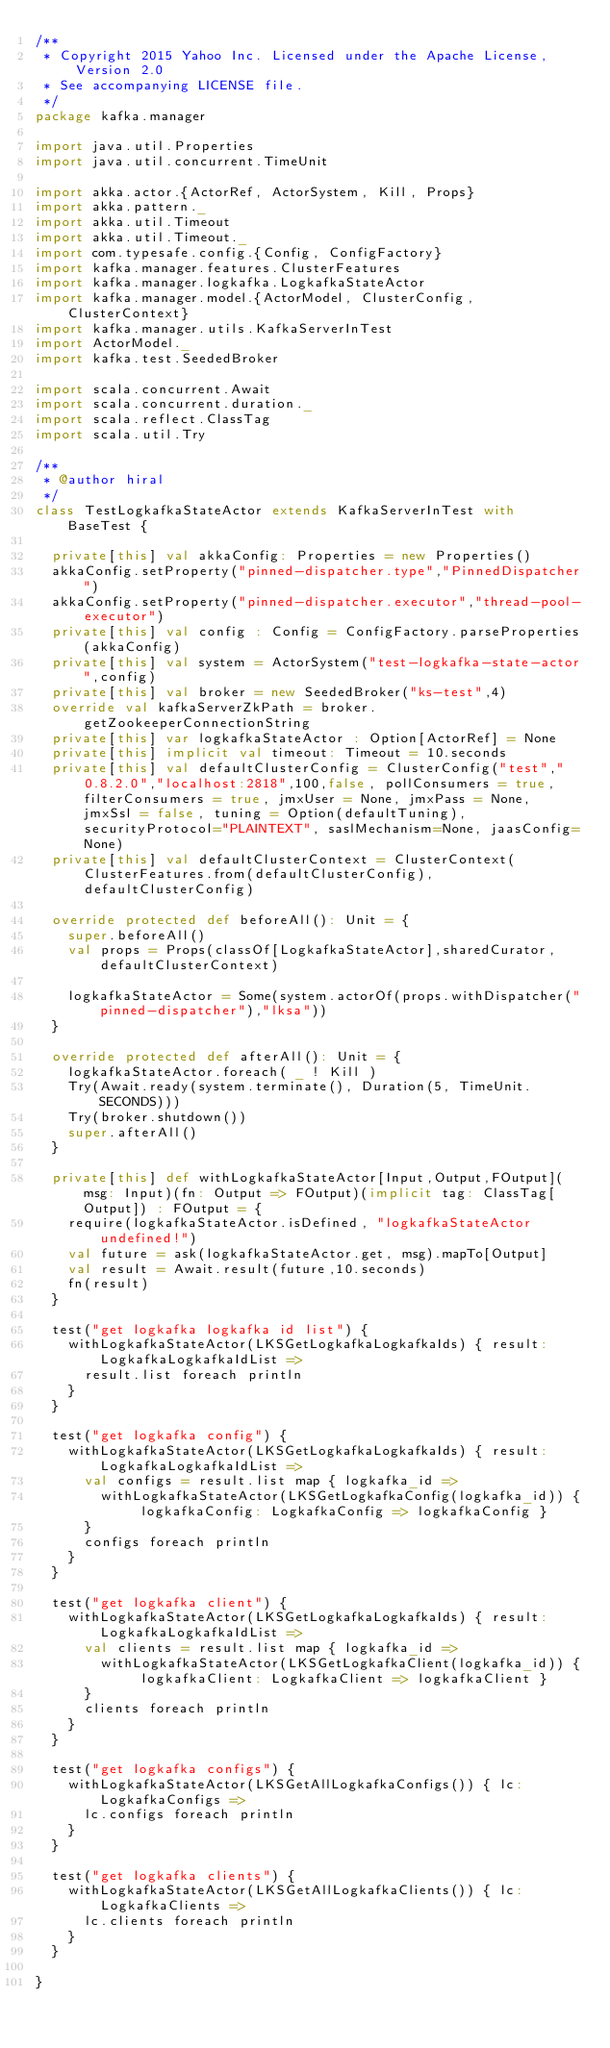Convert code to text. <code><loc_0><loc_0><loc_500><loc_500><_Scala_>/**
 * Copyright 2015 Yahoo Inc. Licensed under the Apache License, Version 2.0
 * See accompanying LICENSE file.
 */
package kafka.manager

import java.util.Properties
import java.util.concurrent.TimeUnit

import akka.actor.{ActorRef, ActorSystem, Kill, Props}
import akka.pattern._
import akka.util.Timeout
import akka.util.Timeout._
import com.typesafe.config.{Config, ConfigFactory}
import kafka.manager.features.ClusterFeatures
import kafka.manager.logkafka.LogkafkaStateActor
import kafka.manager.model.{ActorModel, ClusterConfig, ClusterContext}
import kafka.manager.utils.KafkaServerInTest
import ActorModel._
import kafka.test.SeededBroker

import scala.concurrent.Await
import scala.concurrent.duration._
import scala.reflect.ClassTag
import scala.util.Try

/**
 * @author hiral
 */
class TestLogkafkaStateActor extends KafkaServerInTest with BaseTest {

  private[this] val akkaConfig: Properties = new Properties()
  akkaConfig.setProperty("pinned-dispatcher.type","PinnedDispatcher")
  akkaConfig.setProperty("pinned-dispatcher.executor","thread-pool-executor")
  private[this] val config : Config = ConfigFactory.parseProperties(akkaConfig)
  private[this] val system = ActorSystem("test-logkafka-state-actor",config)
  private[this] val broker = new SeededBroker("ks-test",4)
  override val kafkaServerZkPath = broker.getZookeeperConnectionString
  private[this] var logkafkaStateActor : Option[ActorRef] = None
  private[this] implicit val timeout: Timeout = 10.seconds
  private[this] val defaultClusterConfig = ClusterConfig("test","0.8.2.0","localhost:2818",100,false, pollConsumers = true, filterConsumers = true, jmxUser = None, jmxPass = None, jmxSsl = false, tuning = Option(defaultTuning), securityProtocol="PLAINTEXT", saslMechanism=None, jaasConfig=None)
  private[this] val defaultClusterContext = ClusterContext(ClusterFeatures.from(defaultClusterConfig), defaultClusterConfig)

  override protected def beforeAll(): Unit = {
    super.beforeAll()
    val props = Props(classOf[LogkafkaStateActor],sharedCurator, defaultClusterContext)

    logkafkaStateActor = Some(system.actorOf(props.withDispatcher("pinned-dispatcher"),"lksa"))
  }

  override protected def afterAll(): Unit = {
    logkafkaStateActor.foreach( _ ! Kill )
    Try(Await.ready(system.terminate(), Duration(5, TimeUnit.SECONDS)))
    Try(broker.shutdown())
    super.afterAll()
  }

  private[this] def withLogkafkaStateActor[Input,Output,FOutput](msg: Input)(fn: Output => FOutput)(implicit tag: ClassTag[Output]) : FOutput = {
    require(logkafkaStateActor.isDefined, "logkafkaStateActor undefined!")
    val future = ask(logkafkaStateActor.get, msg).mapTo[Output]
    val result = Await.result(future,10.seconds)
    fn(result)
  }

  test("get logkafka logkafka id list") {
    withLogkafkaStateActor(LKSGetLogkafkaLogkafkaIds) { result: LogkafkaLogkafkaIdList =>
      result.list foreach println
    }
  }

  test("get logkafka config") {
    withLogkafkaStateActor(LKSGetLogkafkaLogkafkaIds) { result: LogkafkaLogkafkaIdList =>
      val configs = result.list map { logkafka_id =>
        withLogkafkaStateActor(LKSGetLogkafkaConfig(logkafka_id)) { logkafkaConfig: LogkafkaConfig => logkafkaConfig }
      }
      configs foreach println
    }
  }

  test("get logkafka client") {
    withLogkafkaStateActor(LKSGetLogkafkaLogkafkaIds) { result: LogkafkaLogkafkaIdList =>
      val clients = result.list map { logkafka_id =>
        withLogkafkaStateActor(LKSGetLogkafkaClient(logkafka_id)) { logkafkaClient: LogkafkaClient => logkafkaClient }
      }
      clients foreach println
    }
  }

  test("get logkafka configs") {
    withLogkafkaStateActor(LKSGetAllLogkafkaConfigs()) { lc: LogkafkaConfigs =>
      lc.configs foreach println
    }
  }

  test("get logkafka clients") {
    withLogkafkaStateActor(LKSGetAllLogkafkaClients()) { lc: LogkafkaClients =>
      lc.clients foreach println
    }
  }

}
</code> 